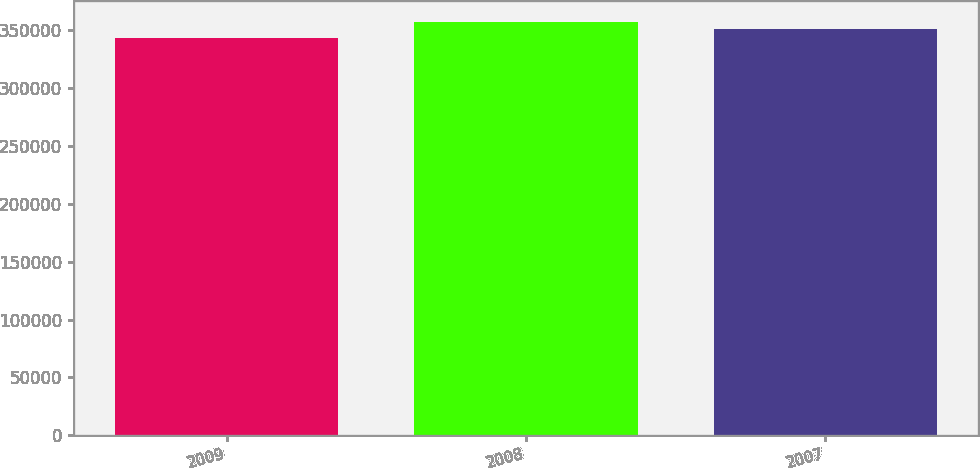Convert chart to OTSL. <chart><loc_0><loc_0><loc_500><loc_500><bar_chart><fcel>2009<fcel>2008<fcel>2007<nl><fcel>343370<fcel>357202<fcel>351209<nl></chart> 